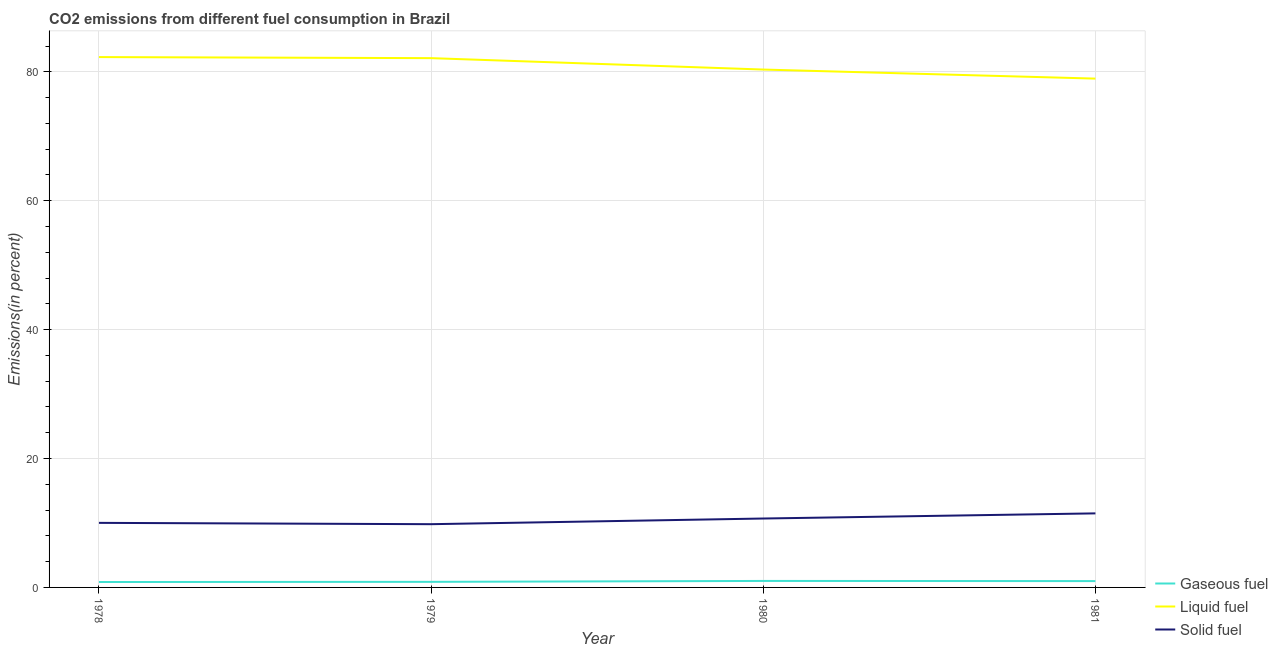How many different coloured lines are there?
Your response must be concise. 3. Is the number of lines equal to the number of legend labels?
Provide a short and direct response. Yes. What is the percentage of solid fuel emission in 1978?
Provide a short and direct response. 10.02. Across all years, what is the maximum percentage of gaseous fuel emission?
Make the answer very short. 1.01. Across all years, what is the minimum percentage of solid fuel emission?
Your response must be concise. 9.81. In which year was the percentage of liquid fuel emission maximum?
Ensure brevity in your answer.  1978. In which year was the percentage of solid fuel emission minimum?
Your answer should be compact. 1979. What is the total percentage of solid fuel emission in the graph?
Your answer should be very brief. 42.01. What is the difference between the percentage of solid fuel emission in 1978 and that in 1980?
Keep it short and to the point. -0.67. What is the difference between the percentage of solid fuel emission in 1980 and the percentage of gaseous fuel emission in 1979?
Your response must be concise. 9.83. What is the average percentage of gaseous fuel emission per year?
Provide a short and direct response. 0.92. In the year 1981, what is the difference between the percentage of solid fuel emission and percentage of gaseous fuel emission?
Provide a succinct answer. 10.51. In how many years, is the percentage of gaseous fuel emission greater than 32 %?
Provide a short and direct response. 0. What is the ratio of the percentage of solid fuel emission in 1978 to that in 1980?
Make the answer very short. 0.94. Is the percentage of solid fuel emission in 1979 less than that in 1980?
Ensure brevity in your answer.  Yes. What is the difference between the highest and the second highest percentage of solid fuel emission?
Make the answer very short. 0.8. What is the difference between the highest and the lowest percentage of solid fuel emission?
Ensure brevity in your answer.  1.68. In how many years, is the percentage of gaseous fuel emission greater than the average percentage of gaseous fuel emission taken over all years?
Offer a terse response. 2. Is it the case that in every year, the sum of the percentage of gaseous fuel emission and percentage of liquid fuel emission is greater than the percentage of solid fuel emission?
Your answer should be compact. Yes. Does the percentage of solid fuel emission monotonically increase over the years?
Offer a terse response. No. Is the percentage of solid fuel emission strictly less than the percentage of liquid fuel emission over the years?
Your answer should be compact. Yes. How many years are there in the graph?
Offer a terse response. 4. What is the difference between two consecutive major ticks on the Y-axis?
Your answer should be very brief. 20. Does the graph contain grids?
Your answer should be very brief. Yes. Where does the legend appear in the graph?
Offer a very short reply. Bottom right. How are the legend labels stacked?
Give a very brief answer. Vertical. What is the title of the graph?
Keep it short and to the point. CO2 emissions from different fuel consumption in Brazil. Does "Maunufacturing" appear as one of the legend labels in the graph?
Your answer should be very brief. No. What is the label or title of the X-axis?
Give a very brief answer. Year. What is the label or title of the Y-axis?
Your answer should be compact. Emissions(in percent). What is the Emissions(in percent) of Gaseous fuel in 1978?
Keep it short and to the point. 0.84. What is the Emissions(in percent) in Liquid fuel in 1978?
Your answer should be very brief. 82.29. What is the Emissions(in percent) of Solid fuel in 1978?
Your response must be concise. 10.02. What is the Emissions(in percent) of Gaseous fuel in 1979?
Your answer should be compact. 0.87. What is the Emissions(in percent) in Liquid fuel in 1979?
Make the answer very short. 82.12. What is the Emissions(in percent) in Solid fuel in 1979?
Offer a very short reply. 9.81. What is the Emissions(in percent) of Gaseous fuel in 1980?
Your response must be concise. 1.01. What is the Emissions(in percent) of Liquid fuel in 1980?
Your answer should be very brief. 80.35. What is the Emissions(in percent) in Solid fuel in 1980?
Your response must be concise. 10.69. What is the Emissions(in percent) in Gaseous fuel in 1981?
Offer a very short reply. 0.98. What is the Emissions(in percent) in Liquid fuel in 1981?
Your response must be concise. 78.95. What is the Emissions(in percent) in Solid fuel in 1981?
Give a very brief answer. 11.49. Across all years, what is the maximum Emissions(in percent) in Gaseous fuel?
Make the answer very short. 1.01. Across all years, what is the maximum Emissions(in percent) of Liquid fuel?
Your response must be concise. 82.29. Across all years, what is the maximum Emissions(in percent) in Solid fuel?
Give a very brief answer. 11.49. Across all years, what is the minimum Emissions(in percent) in Gaseous fuel?
Your answer should be compact. 0.84. Across all years, what is the minimum Emissions(in percent) of Liquid fuel?
Ensure brevity in your answer.  78.95. Across all years, what is the minimum Emissions(in percent) of Solid fuel?
Make the answer very short. 9.81. What is the total Emissions(in percent) in Gaseous fuel in the graph?
Provide a succinct answer. 3.7. What is the total Emissions(in percent) in Liquid fuel in the graph?
Provide a succinct answer. 323.72. What is the total Emissions(in percent) of Solid fuel in the graph?
Ensure brevity in your answer.  42.01. What is the difference between the Emissions(in percent) of Gaseous fuel in 1978 and that in 1979?
Your response must be concise. -0.03. What is the difference between the Emissions(in percent) in Liquid fuel in 1978 and that in 1979?
Keep it short and to the point. 0.17. What is the difference between the Emissions(in percent) of Solid fuel in 1978 and that in 1979?
Keep it short and to the point. 0.21. What is the difference between the Emissions(in percent) of Gaseous fuel in 1978 and that in 1980?
Offer a terse response. -0.17. What is the difference between the Emissions(in percent) in Liquid fuel in 1978 and that in 1980?
Keep it short and to the point. 1.93. What is the difference between the Emissions(in percent) in Solid fuel in 1978 and that in 1980?
Your answer should be compact. -0.67. What is the difference between the Emissions(in percent) in Gaseous fuel in 1978 and that in 1981?
Provide a succinct answer. -0.14. What is the difference between the Emissions(in percent) in Liquid fuel in 1978 and that in 1981?
Your response must be concise. 3.34. What is the difference between the Emissions(in percent) of Solid fuel in 1978 and that in 1981?
Ensure brevity in your answer.  -1.47. What is the difference between the Emissions(in percent) in Gaseous fuel in 1979 and that in 1980?
Make the answer very short. -0.14. What is the difference between the Emissions(in percent) of Liquid fuel in 1979 and that in 1980?
Your response must be concise. 1.77. What is the difference between the Emissions(in percent) of Solid fuel in 1979 and that in 1980?
Your response must be concise. -0.88. What is the difference between the Emissions(in percent) of Gaseous fuel in 1979 and that in 1981?
Offer a very short reply. -0.12. What is the difference between the Emissions(in percent) of Liquid fuel in 1979 and that in 1981?
Keep it short and to the point. 3.17. What is the difference between the Emissions(in percent) of Solid fuel in 1979 and that in 1981?
Your answer should be compact. -1.68. What is the difference between the Emissions(in percent) in Gaseous fuel in 1980 and that in 1981?
Give a very brief answer. 0.03. What is the difference between the Emissions(in percent) in Liquid fuel in 1980 and that in 1981?
Offer a terse response. 1.41. What is the difference between the Emissions(in percent) of Solid fuel in 1980 and that in 1981?
Provide a succinct answer. -0.8. What is the difference between the Emissions(in percent) in Gaseous fuel in 1978 and the Emissions(in percent) in Liquid fuel in 1979?
Ensure brevity in your answer.  -81.28. What is the difference between the Emissions(in percent) of Gaseous fuel in 1978 and the Emissions(in percent) of Solid fuel in 1979?
Give a very brief answer. -8.97. What is the difference between the Emissions(in percent) in Liquid fuel in 1978 and the Emissions(in percent) in Solid fuel in 1979?
Your response must be concise. 72.48. What is the difference between the Emissions(in percent) of Gaseous fuel in 1978 and the Emissions(in percent) of Liquid fuel in 1980?
Your response must be concise. -79.52. What is the difference between the Emissions(in percent) of Gaseous fuel in 1978 and the Emissions(in percent) of Solid fuel in 1980?
Ensure brevity in your answer.  -9.85. What is the difference between the Emissions(in percent) in Liquid fuel in 1978 and the Emissions(in percent) in Solid fuel in 1980?
Ensure brevity in your answer.  71.6. What is the difference between the Emissions(in percent) of Gaseous fuel in 1978 and the Emissions(in percent) of Liquid fuel in 1981?
Your response must be concise. -78.11. What is the difference between the Emissions(in percent) in Gaseous fuel in 1978 and the Emissions(in percent) in Solid fuel in 1981?
Your answer should be compact. -10.65. What is the difference between the Emissions(in percent) of Liquid fuel in 1978 and the Emissions(in percent) of Solid fuel in 1981?
Provide a short and direct response. 70.8. What is the difference between the Emissions(in percent) in Gaseous fuel in 1979 and the Emissions(in percent) in Liquid fuel in 1980?
Ensure brevity in your answer.  -79.49. What is the difference between the Emissions(in percent) of Gaseous fuel in 1979 and the Emissions(in percent) of Solid fuel in 1980?
Keep it short and to the point. -9.83. What is the difference between the Emissions(in percent) of Liquid fuel in 1979 and the Emissions(in percent) of Solid fuel in 1980?
Keep it short and to the point. 71.43. What is the difference between the Emissions(in percent) of Gaseous fuel in 1979 and the Emissions(in percent) of Liquid fuel in 1981?
Your answer should be compact. -78.08. What is the difference between the Emissions(in percent) of Gaseous fuel in 1979 and the Emissions(in percent) of Solid fuel in 1981?
Your answer should be very brief. -10.62. What is the difference between the Emissions(in percent) of Liquid fuel in 1979 and the Emissions(in percent) of Solid fuel in 1981?
Your answer should be very brief. 70.63. What is the difference between the Emissions(in percent) of Gaseous fuel in 1980 and the Emissions(in percent) of Liquid fuel in 1981?
Ensure brevity in your answer.  -77.94. What is the difference between the Emissions(in percent) in Gaseous fuel in 1980 and the Emissions(in percent) in Solid fuel in 1981?
Make the answer very short. -10.48. What is the difference between the Emissions(in percent) of Liquid fuel in 1980 and the Emissions(in percent) of Solid fuel in 1981?
Your answer should be very brief. 68.87. What is the average Emissions(in percent) of Gaseous fuel per year?
Make the answer very short. 0.92. What is the average Emissions(in percent) in Liquid fuel per year?
Your answer should be compact. 80.93. What is the average Emissions(in percent) of Solid fuel per year?
Ensure brevity in your answer.  10.5. In the year 1978, what is the difference between the Emissions(in percent) in Gaseous fuel and Emissions(in percent) in Liquid fuel?
Offer a very short reply. -81.45. In the year 1978, what is the difference between the Emissions(in percent) of Gaseous fuel and Emissions(in percent) of Solid fuel?
Offer a terse response. -9.18. In the year 1978, what is the difference between the Emissions(in percent) of Liquid fuel and Emissions(in percent) of Solid fuel?
Provide a succinct answer. 72.27. In the year 1979, what is the difference between the Emissions(in percent) in Gaseous fuel and Emissions(in percent) in Liquid fuel?
Offer a terse response. -81.26. In the year 1979, what is the difference between the Emissions(in percent) in Gaseous fuel and Emissions(in percent) in Solid fuel?
Your answer should be compact. -8.95. In the year 1979, what is the difference between the Emissions(in percent) in Liquid fuel and Emissions(in percent) in Solid fuel?
Your response must be concise. 72.31. In the year 1980, what is the difference between the Emissions(in percent) in Gaseous fuel and Emissions(in percent) in Liquid fuel?
Offer a terse response. -79.35. In the year 1980, what is the difference between the Emissions(in percent) of Gaseous fuel and Emissions(in percent) of Solid fuel?
Ensure brevity in your answer.  -9.68. In the year 1980, what is the difference between the Emissions(in percent) in Liquid fuel and Emissions(in percent) in Solid fuel?
Keep it short and to the point. 69.66. In the year 1981, what is the difference between the Emissions(in percent) in Gaseous fuel and Emissions(in percent) in Liquid fuel?
Ensure brevity in your answer.  -77.97. In the year 1981, what is the difference between the Emissions(in percent) of Gaseous fuel and Emissions(in percent) of Solid fuel?
Provide a short and direct response. -10.51. In the year 1981, what is the difference between the Emissions(in percent) in Liquid fuel and Emissions(in percent) in Solid fuel?
Your answer should be very brief. 67.46. What is the ratio of the Emissions(in percent) of Gaseous fuel in 1978 to that in 1979?
Your answer should be compact. 0.97. What is the ratio of the Emissions(in percent) in Liquid fuel in 1978 to that in 1979?
Keep it short and to the point. 1. What is the ratio of the Emissions(in percent) in Solid fuel in 1978 to that in 1979?
Provide a succinct answer. 1.02. What is the ratio of the Emissions(in percent) of Gaseous fuel in 1978 to that in 1980?
Offer a terse response. 0.83. What is the ratio of the Emissions(in percent) of Liquid fuel in 1978 to that in 1980?
Your answer should be very brief. 1.02. What is the ratio of the Emissions(in percent) of Solid fuel in 1978 to that in 1980?
Ensure brevity in your answer.  0.94. What is the ratio of the Emissions(in percent) of Gaseous fuel in 1978 to that in 1981?
Your answer should be very brief. 0.85. What is the ratio of the Emissions(in percent) of Liquid fuel in 1978 to that in 1981?
Keep it short and to the point. 1.04. What is the ratio of the Emissions(in percent) of Solid fuel in 1978 to that in 1981?
Provide a short and direct response. 0.87. What is the ratio of the Emissions(in percent) in Gaseous fuel in 1979 to that in 1980?
Offer a very short reply. 0.86. What is the ratio of the Emissions(in percent) of Solid fuel in 1979 to that in 1980?
Offer a terse response. 0.92. What is the ratio of the Emissions(in percent) in Gaseous fuel in 1979 to that in 1981?
Provide a succinct answer. 0.88. What is the ratio of the Emissions(in percent) of Liquid fuel in 1979 to that in 1981?
Offer a very short reply. 1.04. What is the ratio of the Emissions(in percent) of Solid fuel in 1979 to that in 1981?
Provide a succinct answer. 0.85. What is the ratio of the Emissions(in percent) in Gaseous fuel in 1980 to that in 1981?
Make the answer very short. 1.03. What is the ratio of the Emissions(in percent) in Liquid fuel in 1980 to that in 1981?
Your response must be concise. 1.02. What is the ratio of the Emissions(in percent) of Solid fuel in 1980 to that in 1981?
Ensure brevity in your answer.  0.93. What is the difference between the highest and the second highest Emissions(in percent) of Gaseous fuel?
Your answer should be very brief. 0.03. What is the difference between the highest and the second highest Emissions(in percent) in Liquid fuel?
Make the answer very short. 0.17. What is the difference between the highest and the second highest Emissions(in percent) in Solid fuel?
Give a very brief answer. 0.8. What is the difference between the highest and the lowest Emissions(in percent) of Gaseous fuel?
Your answer should be compact. 0.17. What is the difference between the highest and the lowest Emissions(in percent) of Liquid fuel?
Provide a short and direct response. 3.34. What is the difference between the highest and the lowest Emissions(in percent) in Solid fuel?
Your answer should be very brief. 1.68. 